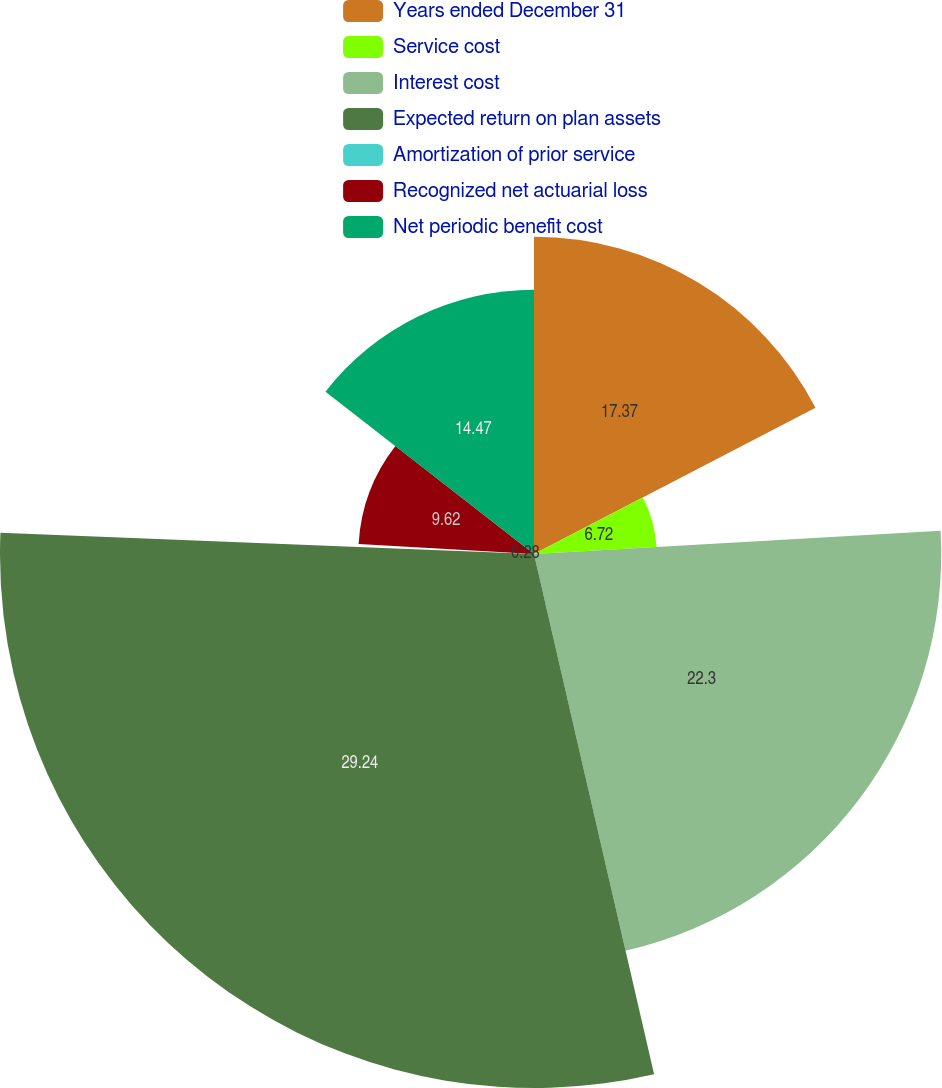Convert chart. <chart><loc_0><loc_0><loc_500><loc_500><pie_chart><fcel>Years ended December 31<fcel>Service cost<fcel>Interest cost<fcel>Expected return on plan assets<fcel>Amortization of prior service<fcel>Recognized net actuarial loss<fcel>Net periodic benefit cost<nl><fcel>17.37%<fcel>6.72%<fcel>22.3%<fcel>29.24%<fcel>0.28%<fcel>9.62%<fcel>14.47%<nl></chart> 